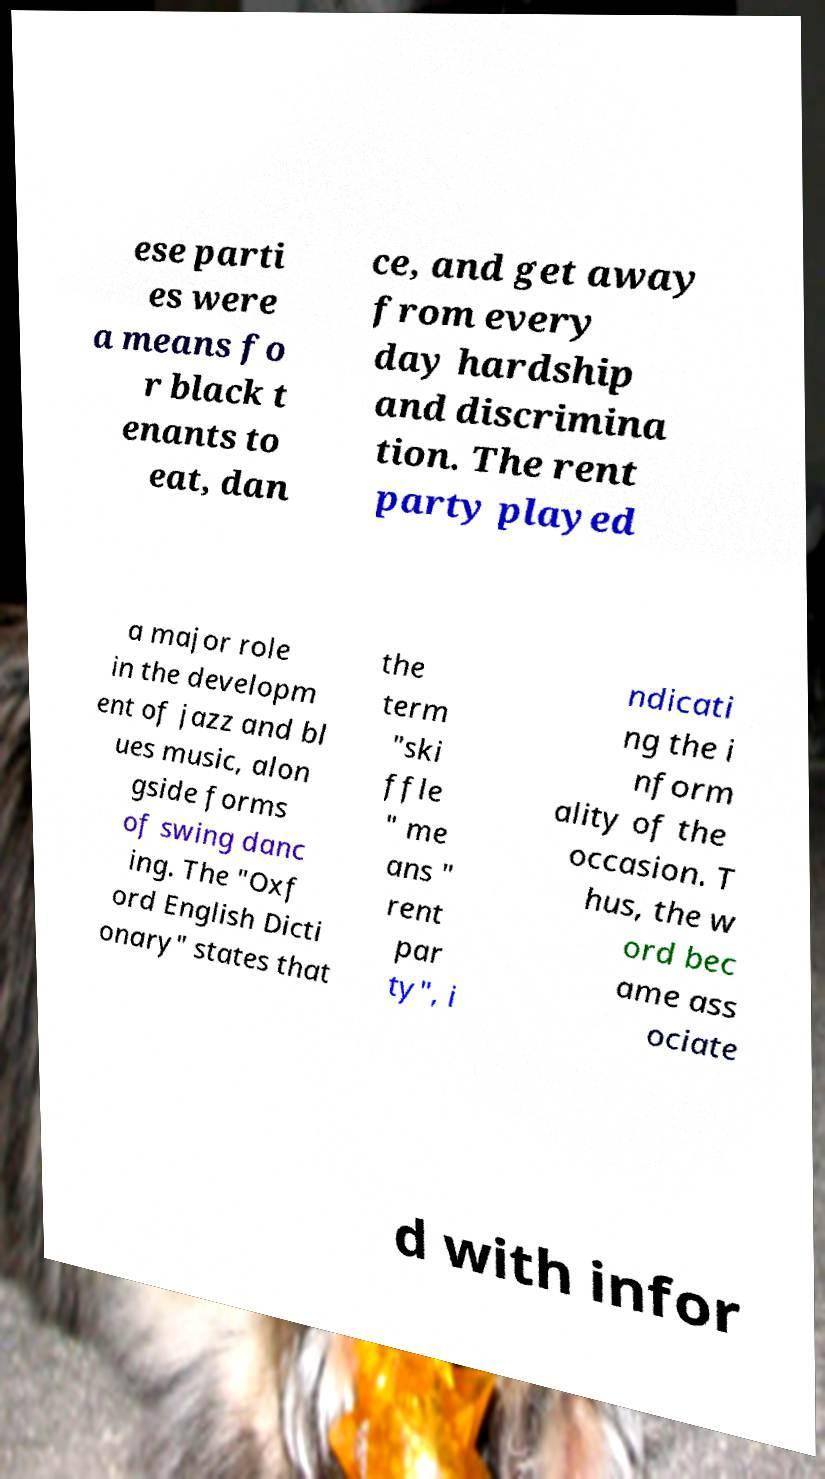There's text embedded in this image that I need extracted. Can you transcribe it verbatim? ese parti es were a means fo r black t enants to eat, dan ce, and get away from every day hardship and discrimina tion. The rent party played a major role in the developm ent of jazz and bl ues music, alon gside forms of swing danc ing. The "Oxf ord English Dicti onary" states that the term "ski ffle " me ans " rent par ty", i ndicati ng the i nform ality of the occasion. T hus, the w ord bec ame ass ociate d with infor 